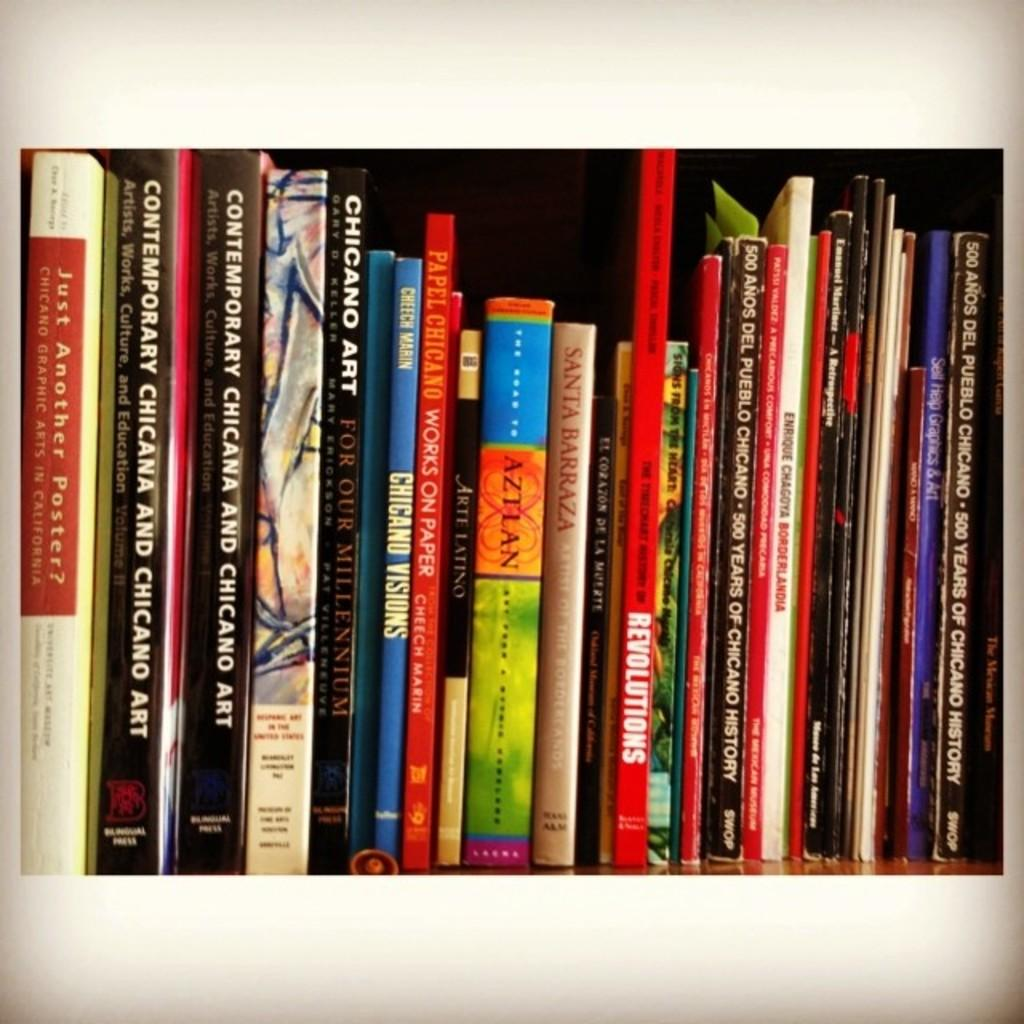<image>
Write a terse but informative summary of the picture. Several books are on a shelf, including "Chicano Art." 